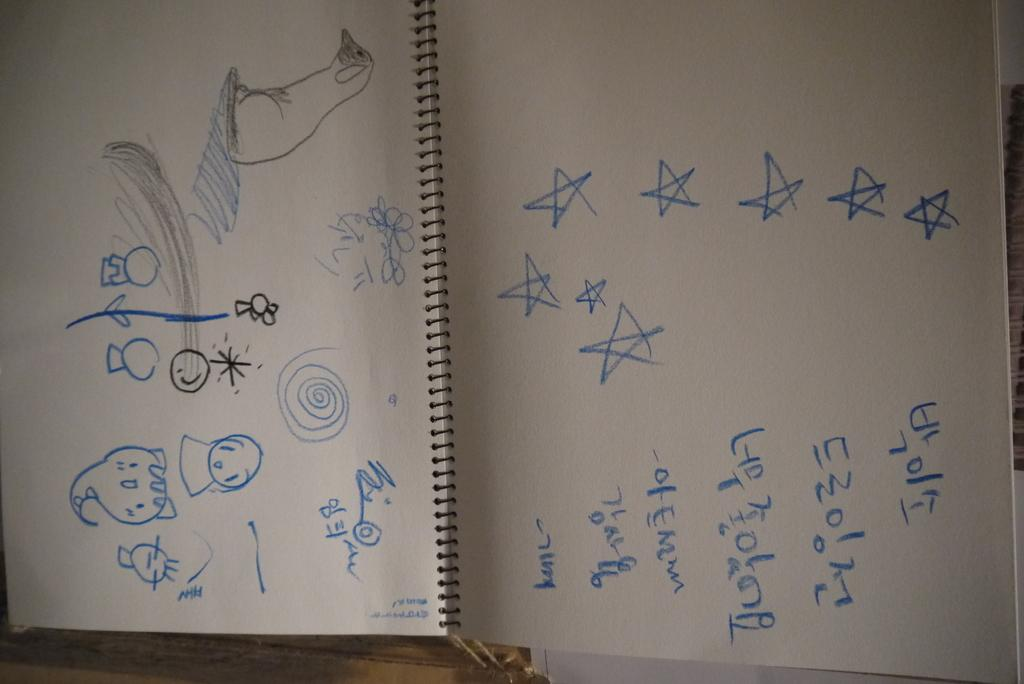What is present on the papers in the image? There are diagrams and numbers on the papers. Can you describe the type of content on the papers? The papers contain diagrams and numbers, which may suggest that they are related to a technical or mathematical subject. What type of vegetable is growing on the wall in the image? There is no vegetable growing on a wall in the image; the image only contains papers with diagrams and numbers. 